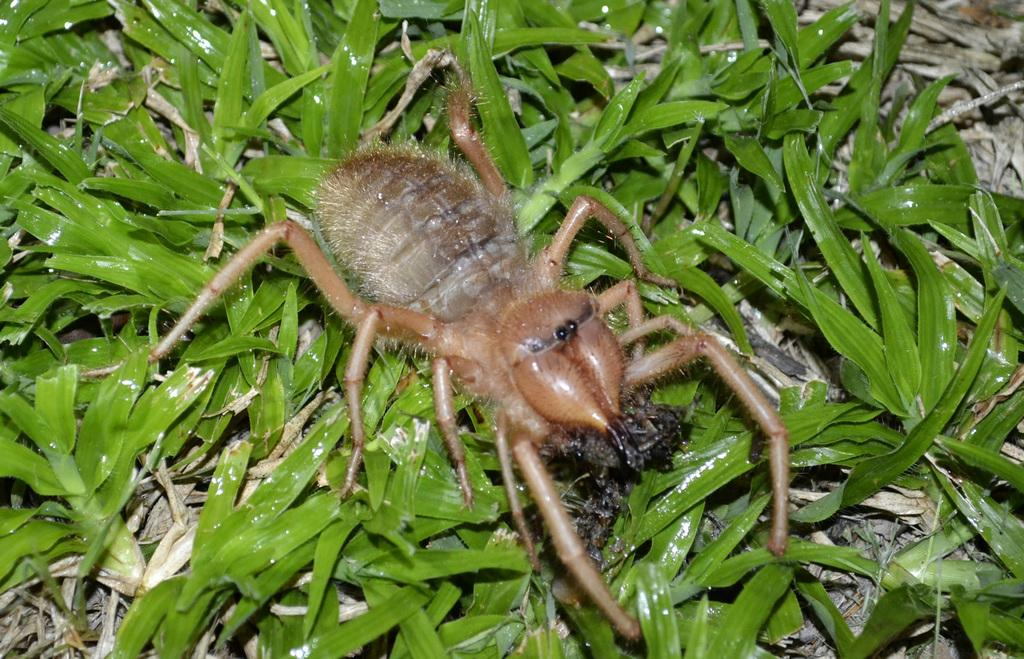What is the main subject in the center of the image? There is an insect in the center of the image, which appears to be a spider. What type of vegetation is present in the image? There are green leaves in the image. Are there any other items visible in the image besides the spider and leaves? Yes, there are other items visible in the image. What type of noise can be heard coming from the loaf in the image? There is no loaf present in the image, so it is not possible to determine what type of noise might be heard. 